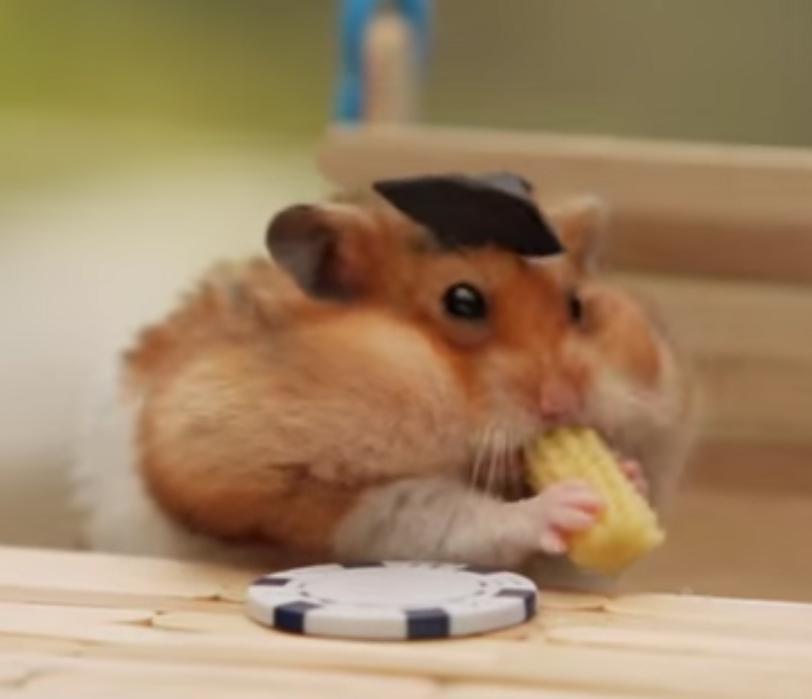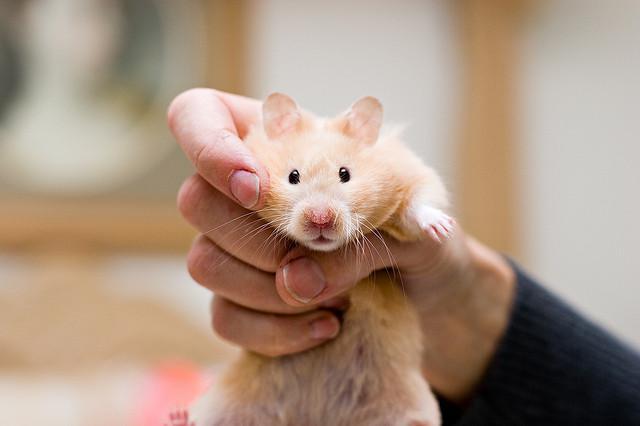The first image is the image on the left, the second image is the image on the right. For the images displayed, is the sentence "Each image shows a hamster that is eating." factually correct? Answer yes or no. No. 